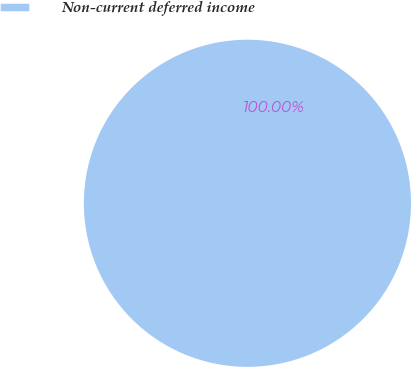Convert chart to OTSL. <chart><loc_0><loc_0><loc_500><loc_500><pie_chart><fcel>Non-current deferred income<nl><fcel>100.0%<nl></chart> 